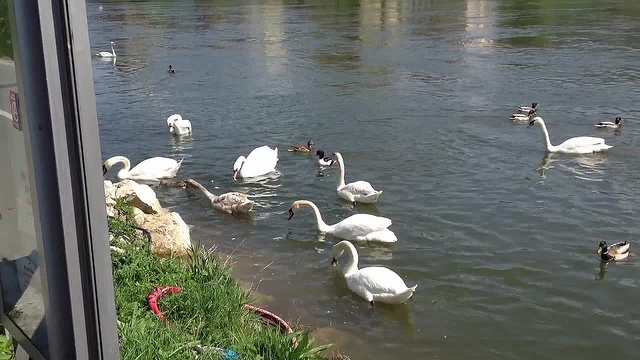Describe the objects in this image and their specific colors. I can see bird in darkgreen, white, gray, darkgray, and black tones, bird in darkgreen, white, gray, darkgray, and black tones, bird in darkgreen, white, darkgray, gray, and lightgray tones, bird in darkgreen, white, gray, darkgray, and black tones, and bird in darkgreen, gray, lightgray, darkgray, and black tones in this image. 